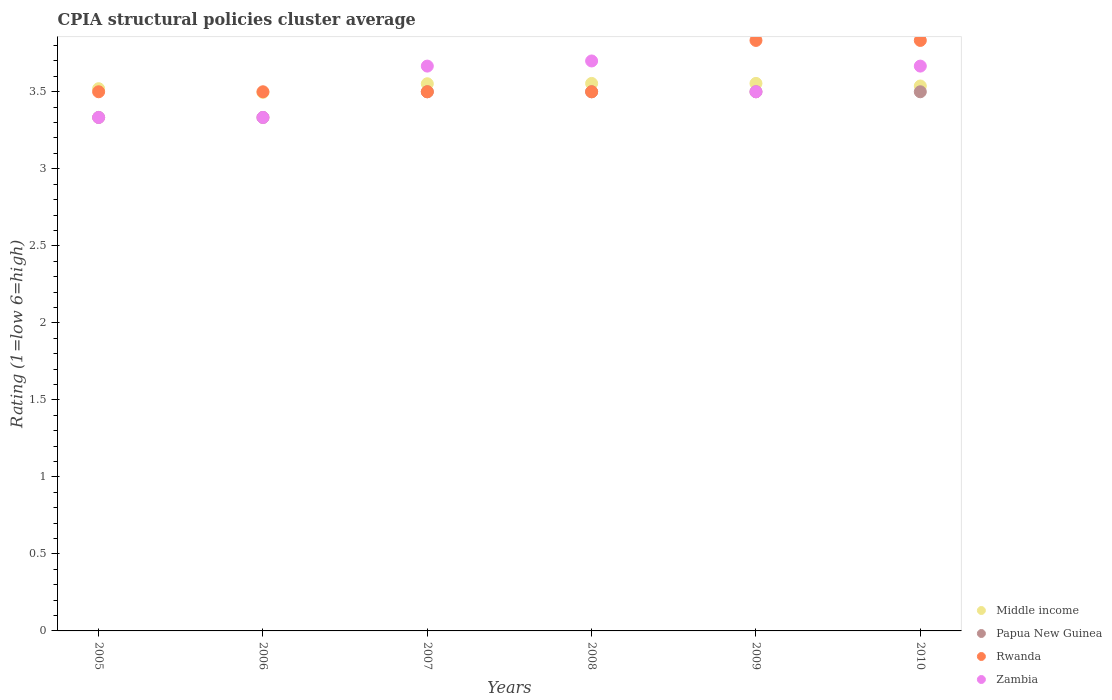What is the CPIA rating in Middle income in 2007?
Give a very brief answer. 3.55. Across all years, what is the maximum CPIA rating in Rwanda?
Provide a succinct answer. 3.83. Across all years, what is the minimum CPIA rating in Papua New Guinea?
Ensure brevity in your answer.  3.33. In which year was the CPIA rating in Rwanda minimum?
Ensure brevity in your answer.  2005. What is the total CPIA rating in Papua New Guinea in the graph?
Offer a terse response. 20.67. What is the difference between the CPIA rating in Rwanda in 2005 and that in 2008?
Your response must be concise. 0. What is the difference between the CPIA rating in Papua New Guinea in 2005 and the CPIA rating in Middle income in 2010?
Provide a short and direct response. -0.2. What is the average CPIA rating in Middle income per year?
Offer a terse response. 3.54. In the year 2005, what is the difference between the CPIA rating in Rwanda and CPIA rating in Papua New Guinea?
Provide a short and direct response. 0.17. In how many years, is the CPIA rating in Papua New Guinea greater than 3.6?
Keep it short and to the point. 0. What is the ratio of the CPIA rating in Rwanda in 2009 to that in 2010?
Provide a short and direct response. 1. What is the difference between the highest and the lowest CPIA rating in Middle income?
Offer a terse response. 0.06. In how many years, is the CPIA rating in Zambia greater than the average CPIA rating in Zambia taken over all years?
Provide a succinct answer. 3. Is the CPIA rating in Zambia strictly greater than the CPIA rating in Middle income over the years?
Make the answer very short. No. How many years are there in the graph?
Offer a terse response. 6. Are the values on the major ticks of Y-axis written in scientific E-notation?
Your answer should be compact. No. Does the graph contain any zero values?
Your answer should be very brief. No. Does the graph contain grids?
Your response must be concise. No. Where does the legend appear in the graph?
Provide a succinct answer. Bottom right. How many legend labels are there?
Give a very brief answer. 4. How are the legend labels stacked?
Keep it short and to the point. Vertical. What is the title of the graph?
Your response must be concise. CPIA structural policies cluster average. What is the label or title of the X-axis?
Your answer should be very brief. Years. What is the label or title of the Y-axis?
Offer a terse response. Rating (1=low 6=high). What is the Rating (1=low 6=high) in Middle income in 2005?
Keep it short and to the point. 3.52. What is the Rating (1=low 6=high) in Papua New Guinea in 2005?
Make the answer very short. 3.33. What is the Rating (1=low 6=high) in Zambia in 2005?
Your answer should be very brief. 3.33. What is the Rating (1=low 6=high) of Middle income in 2006?
Offer a very short reply. 3.5. What is the Rating (1=low 6=high) in Papua New Guinea in 2006?
Make the answer very short. 3.33. What is the Rating (1=low 6=high) of Rwanda in 2006?
Your answer should be compact. 3.5. What is the Rating (1=low 6=high) in Zambia in 2006?
Your answer should be very brief. 3.33. What is the Rating (1=low 6=high) of Middle income in 2007?
Make the answer very short. 3.55. What is the Rating (1=low 6=high) of Rwanda in 2007?
Your answer should be very brief. 3.5. What is the Rating (1=low 6=high) in Zambia in 2007?
Give a very brief answer. 3.67. What is the Rating (1=low 6=high) of Middle income in 2008?
Give a very brief answer. 3.55. What is the Rating (1=low 6=high) of Papua New Guinea in 2008?
Give a very brief answer. 3.5. What is the Rating (1=low 6=high) of Rwanda in 2008?
Keep it short and to the point. 3.5. What is the Rating (1=low 6=high) of Middle income in 2009?
Your response must be concise. 3.55. What is the Rating (1=low 6=high) in Rwanda in 2009?
Make the answer very short. 3.83. What is the Rating (1=low 6=high) in Zambia in 2009?
Make the answer very short. 3.5. What is the Rating (1=low 6=high) in Middle income in 2010?
Provide a short and direct response. 3.54. What is the Rating (1=low 6=high) in Papua New Guinea in 2010?
Ensure brevity in your answer.  3.5. What is the Rating (1=low 6=high) of Rwanda in 2010?
Provide a short and direct response. 3.83. What is the Rating (1=low 6=high) in Zambia in 2010?
Make the answer very short. 3.67. Across all years, what is the maximum Rating (1=low 6=high) of Middle income?
Give a very brief answer. 3.55. Across all years, what is the maximum Rating (1=low 6=high) in Papua New Guinea?
Ensure brevity in your answer.  3.5. Across all years, what is the maximum Rating (1=low 6=high) of Rwanda?
Your response must be concise. 3.83. Across all years, what is the maximum Rating (1=low 6=high) in Zambia?
Ensure brevity in your answer.  3.7. Across all years, what is the minimum Rating (1=low 6=high) of Middle income?
Offer a terse response. 3.5. Across all years, what is the minimum Rating (1=low 6=high) in Papua New Guinea?
Ensure brevity in your answer.  3.33. Across all years, what is the minimum Rating (1=low 6=high) of Rwanda?
Ensure brevity in your answer.  3.5. Across all years, what is the minimum Rating (1=low 6=high) of Zambia?
Keep it short and to the point. 3.33. What is the total Rating (1=low 6=high) of Middle income in the graph?
Your response must be concise. 21.21. What is the total Rating (1=low 6=high) of Papua New Guinea in the graph?
Offer a very short reply. 20.67. What is the total Rating (1=low 6=high) in Rwanda in the graph?
Provide a short and direct response. 21.67. What is the total Rating (1=low 6=high) of Zambia in the graph?
Keep it short and to the point. 21.2. What is the difference between the Rating (1=low 6=high) of Middle income in 2005 and that in 2006?
Your response must be concise. 0.02. What is the difference between the Rating (1=low 6=high) in Rwanda in 2005 and that in 2006?
Provide a succinct answer. 0. What is the difference between the Rating (1=low 6=high) in Zambia in 2005 and that in 2006?
Provide a short and direct response. 0. What is the difference between the Rating (1=low 6=high) in Middle income in 2005 and that in 2007?
Give a very brief answer. -0.03. What is the difference between the Rating (1=low 6=high) in Rwanda in 2005 and that in 2007?
Your answer should be very brief. 0. What is the difference between the Rating (1=low 6=high) of Middle income in 2005 and that in 2008?
Your answer should be compact. -0.03. What is the difference between the Rating (1=low 6=high) in Rwanda in 2005 and that in 2008?
Provide a succinct answer. 0. What is the difference between the Rating (1=low 6=high) of Zambia in 2005 and that in 2008?
Your answer should be compact. -0.37. What is the difference between the Rating (1=low 6=high) in Middle income in 2005 and that in 2009?
Your response must be concise. -0.03. What is the difference between the Rating (1=low 6=high) of Rwanda in 2005 and that in 2009?
Provide a short and direct response. -0.33. What is the difference between the Rating (1=low 6=high) of Zambia in 2005 and that in 2009?
Ensure brevity in your answer.  -0.17. What is the difference between the Rating (1=low 6=high) in Middle income in 2005 and that in 2010?
Provide a succinct answer. -0.02. What is the difference between the Rating (1=low 6=high) in Zambia in 2005 and that in 2010?
Keep it short and to the point. -0.33. What is the difference between the Rating (1=low 6=high) of Middle income in 2006 and that in 2007?
Provide a succinct answer. -0.06. What is the difference between the Rating (1=low 6=high) of Zambia in 2006 and that in 2007?
Give a very brief answer. -0.33. What is the difference between the Rating (1=low 6=high) of Middle income in 2006 and that in 2008?
Offer a terse response. -0.06. What is the difference between the Rating (1=low 6=high) in Rwanda in 2006 and that in 2008?
Your answer should be compact. 0. What is the difference between the Rating (1=low 6=high) of Zambia in 2006 and that in 2008?
Offer a terse response. -0.37. What is the difference between the Rating (1=low 6=high) in Middle income in 2006 and that in 2009?
Provide a short and direct response. -0.06. What is the difference between the Rating (1=low 6=high) in Zambia in 2006 and that in 2009?
Your answer should be compact. -0.17. What is the difference between the Rating (1=low 6=high) of Middle income in 2006 and that in 2010?
Offer a terse response. -0.04. What is the difference between the Rating (1=low 6=high) in Papua New Guinea in 2006 and that in 2010?
Make the answer very short. -0.17. What is the difference between the Rating (1=low 6=high) in Zambia in 2006 and that in 2010?
Keep it short and to the point. -0.33. What is the difference between the Rating (1=low 6=high) of Middle income in 2007 and that in 2008?
Ensure brevity in your answer.  -0. What is the difference between the Rating (1=low 6=high) in Papua New Guinea in 2007 and that in 2008?
Make the answer very short. 0. What is the difference between the Rating (1=low 6=high) in Rwanda in 2007 and that in 2008?
Provide a short and direct response. 0. What is the difference between the Rating (1=low 6=high) of Zambia in 2007 and that in 2008?
Your response must be concise. -0.03. What is the difference between the Rating (1=low 6=high) of Middle income in 2007 and that in 2009?
Ensure brevity in your answer.  -0. What is the difference between the Rating (1=low 6=high) of Middle income in 2007 and that in 2010?
Provide a succinct answer. 0.01. What is the difference between the Rating (1=low 6=high) of Middle income in 2008 and that in 2009?
Provide a succinct answer. -0. What is the difference between the Rating (1=low 6=high) of Zambia in 2008 and that in 2009?
Ensure brevity in your answer.  0.2. What is the difference between the Rating (1=low 6=high) of Middle income in 2008 and that in 2010?
Your response must be concise. 0.02. What is the difference between the Rating (1=low 6=high) in Papua New Guinea in 2008 and that in 2010?
Ensure brevity in your answer.  0. What is the difference between the Rating (1=low 6=high) in Rwanda in 2008 and that in 2010?
Your response must be concise. -0.33. What is the difference between the Rating (1=low 6=high) in Zambia in 2008 and that in 2010?
Your response must be concise. 0.03. What is the difference between the Rating (1=low 6=high) of Middle income in 2009 and that in 2010?
Make the answer very short. 0.02. What is the difference between the Rating (1=low 6=high) in Papua New Guinea in 2009 and that in 2010?
Give a very brief answer. 0. What is the difference between the Rating (1=low 6=high) in Zambia in 2009 and that in 2010?
Your answer should be very brief. -0.17. What is the difference between the Rating (1=low 6=high) in Middle income in 2005 and the Rating (1=low 6=high) in Papua New Guinea in 2006?
Ensure brevity in your answer.  0.19. What is the difference between the Rating (1=low 6=high) of Middle income in 2005 and the Rating (1=low 6=high) of Zambia in 2006?
Offer a very short reply. 0.19. What is the difference between the Rating (1=low 6=high) of Papua New Guinea in 2005 and the Rating (1=low 6=high) of Zambia in 2006?
Ensure brevity in your answer.  0. What is the difference between the Rating (1=low 6=high) in Middle income in 2005 and the Rating (1=low 6=high) in Papua New Guinea in 2007?
Make the answer very short. 0.02. What is the difference between the Rating (1=low 6=high) in Middle income in 2005 and the Rating (1=low 6=high) in Zambia in 2007?
Your answer should be very brief. -0.15. What is the difference between the Rating (1=low 6=high) of Rwanda in 2005 and the Rating (1=low 6=high) of Zambia in 2007?
Offer a terse response. -0.17. What is the difference between the Rating (1=low 6=high) of Middle income in 2005 and the Rating (1=low 6=high) of Papua New Guinea in 2008?
Give a very brief answer. 0.02. What is the difference between the Rating (1=low 6=high) in Middle income in 2005 and the Rating (1=low 6=high) in Zambia in 2008?
Your answer should be compact. -0.18. What is the difference between the Rating (1=low 6=high) of Papua New Guinea in 2005 and the Rating (1=low 6=high) of Rwanda in 2008?
Your response must be concise. -0.17. What is the difference between the Rating (1=low 6=high) of Papua New Guinea in 2005 and the Rating (1=low 6=high) of Zambia in 2008?
Provide a succinct answer. -0.37. What is the difference between the Rating (1=low 6=high) in Middle income in 2005 and the Rating (1=low 6=high) in Papua New Guinea in 2009?
Provide a succinct answer. 0.02. What is the difference between the Rating (1=low 6=high) of Middle income in 2005 and the Rating (1=low 6=high) of Rwanda in 2009?
Your response must be concise. -0.31. What is the difference between the Rating (1=low 6=high) of Middle income in 2005 and the Rating (1=low 6=high) of Zambia in 2009?
Ensure brevity in your answer.  0.02. What is the difference between the Rating (1=low 6=high) of Middle income in 2005 and the Rating (1=low 6=high) of Papua New Guinea in 2010?
Your response must be concise. 0.02. What is the difference between the Rating (1=low 6=high) in Middle income in 2005 and the Rating (1=low 6=high) in Rwanda in 2010?
Offer a very short reply. -0.31. What is the difference between the Rating (1=low 6=high) of Middle income in 2005 and the Rating (1=low 6=high) of Zambia in 2010?
Keep it short and to the point. -0.15. What is the difference between the Rating (1=low 6=high) of Rwanda in 2005 and the Rating (1=low 6=high) of Zambia in 2010?
Provide a short and direct response. -0.17. What is the difference between the Rating (1=low 6=high) of Middle income in 2006 and the Rating (1=low 6=high) of Papua New Guinea in 2007?
Your answer should be very brief. -0. What is the difference between the Rating (1=low 6=high) of Middle income in 2006 and the Rating (1=low 6=high) of Rwanda in 2007?
Keep it short and to the point. -0. What is the difference between the Rating (1=low 6=high) of Middle income in 2006 and the Rating (1=low 6=high) of Zambia in 2007?
Provide a short and direct response. -0.17. What is the difference between the Rating (1=low 6=high) of Rwanda in 2006 and the Rating (1=low 6=high) of Zambia in 2007?
Your response must be concise. -0.17. What is the difference between the Rating (1=low 6=high) of Middle income in 2006 and the Rating (1=low 6=high) of Papua New Guinea in 2008?
Your answer should be compact. -0. What is the difference between the Rating (1=low 6=high) in Middle income in 2006 and the Rating (1=low 6=high) in Rwanda in 2008?
Your answer should be compact. -0. What is the difference between the Rating (1=low 6=high) in Middle income in 2006 and the Rating (1=low 6=high) in Zambia in 2008?
Make the answer very short. -0.2. What is the difference between the Rating (1=low 6=high) in Papua New Guinea in 2006 and the Rating (1=low 6=high) in Zambia in 2008?
Make the answer very short. -0.37. What is the difference between the Rating (1=low 6=high) of Rwanda in 2006 and the Rating (1=low 6=high) of Zambia in 2008?
Offer a terse response. -0.2. What is the difference between the Rating (1=low 6=high) in Middle income in 2006 and the Rating (1=low 6=high) in Papua New Guinea in 2009?
Your response must be concise. -0. What is the difference between the Rating (1=low 6=high) in Middle income in 2006 and the Rating (1=low 6=high) in Rwanda in 2009?
Offer a terse response. -0.34. What is the difference between the Rating (1=low 6=high) of Middle income in 2006 and the Rating (1=low 6=high) of Zambia in 2009?
Your answer should be compact. -0. What is the difference between the Rating (1=low 6=high) of Papua New Guinea in 2006 and the Rating (1=low 6=high) of Rwanda in 2009?
Your answer should be compact. -0.5. What is the difference between the Rating (1=low 6=high) in Rwanda in 2006 and the Rating (1=low 6=high) in Zambia in 2009?
Ensure brevity in your answer.  0. What is the difference between the Rating (1=low 6=high) in Middle income in 2006 and the Rating (1=low 6=high) in Papua New Guinea in 2010?
Provide a succinct answer. -0. What is the difference between the Rating (1=low 6=high) in Middle income in 2006 and the Rating (1=low 6=high) in Rwanda in 2010?
Your answer should be compact. -0.34. What is the difference between the Rating (1=low 6=high) in Middle income in 2006 and the Rating (1=low 6=high) in Zambia in 2010?
Offer a terse response. -0.17. What is the difference between the Rating (1=low 6=high) in Papua New Guinea in 2006 and the Rating (1=low 6=high) in Rwanda in 2010?
Give a very brief answer. -0.5. What is the difference between the Rating (1=low 6=high) in Middle income in 2007 and the Rating (1=low 6=high) in Papua New Guinea in 2008?
Give a very brief answer. 0.05. What is the difference between the Rating (1=low 6=high) of Middle income in 2007 and the Rating (1=low 6=high) of Rwanda in 2008?
Your response must be concise. 0.05. What is the difference between the Rating (1=low 6=high) of Middle income in 2007 and the Rating (1=low 6=high) of Zambia in 2008?
Your response must be concise. -0.15. What is the difference between the Rating (1=low 6=high) of Papua New Guinea in 2007 and the Rating (1=low 6=high) of Rwanda in 2008?
Your response must be concise. 0. What is the difference between the Rating (1=low 6=high) of Rwanda in 2007 and the Rating (1=low 6=high) of Zambia in 2008?
Offer a very short reply. -0.2. What is the difference between the Rating (1=low 6=high) in Middle income in 2007 and the Rating (1=low 6=high) in Papua New Guinea in 2009?
Keep it short and to the point. 0.05. What is the difference between the Rating (1=low 6=high) in Middle income in 2007 and the Rating (1=low 6=high) in Rwanda in 2009?
Provide a short and direct response. -0.28. What is the difference between the Rating (1=low 6=high) of Middle income in 2007 and the Rating (1=low 6=high) of Zambia in 2009?
Your response must be concise. 0.05. What is the difference between the Rating (1=low 6=high) of Papua New Guinea in 2007 and the Rating (1=low 6=high) of Rwanda in 2009?
Offer a very short reply. -0.33. What is the difference between the Rating (1=low 6=high) of Papua New Guinea in 2007 and the Rating (1=low 6=high) of Zambia in 2009?
Provide a succinct answer. 0. What is the difference between the Rating (1=low 6=high) in Middle income in 2007 and the Rating (1=low 6=high) in Papua New Guinea in 2010?
Your answer should be compact. 0.05. What is the difference between the Rating (1=low 6=high) of Middle income in 2007 and the Rating (1=low 6=high) of Rwanda in 2010?
Give a very brief answer. -0.28. What is the difference between the Rating (1=low 6=high) of Middle income in 2007 and the Rating (1=low 6=high) of Zambia in 2010?
Give a very brief answer. -0.11. What is the difference between the Rating (1=low 6=high) of Papua New Guinea in 2007 and the Rating (1=low 6=high) of Rwanda in 2010?
Give a very brief answer. -0.33. What is the difference between the Rating (1=low 6=high) in Papua New Guinea in 2007 and the Rating (1=low 6=high) in Zambia in 2010?
Ensure brevity in your answer.  -0.17. What is the difference between the Rating (1=low 6=high) in Middle income in 2008 and the Rating (1=low 6=high) in Papua New Guinea in 2009?
Your answer should be compact. 0.05. What is the difference between the Rating (1=low 6=high) in Middle income in 2008 and the Rating (1=low 6=high) in Rwanda in 2009?
Offer a very short reply. -0.28. What is the difference between the Rating (1=low 6=high) in Middle income in 2008 and the Rating (1=low 6=high) in Zambia in 2009?
Make the answer very short. 0.05. What is the difference between the Rating (1=low 6=high) in Papua New Guinea in 2008 and the Rating (1=low 6=high) in Zambia in 2009?
Provide a succinct answer. 0. What is the difference between the Rating (1=low 6=high) in Rwanda in 2008 and the Rating (1=low 6=high) in Zambia in 2009?
Ensure brevity in your answer.  0. What is the difference between the Rating (1=low 6=high) of Middle income in 2008 and the Rating (1=low 6=high) of Papua New Guinea in 2010?
Ensure brevity in your answer.  0.05. What is the difference between the Rating (1=low 6=high) of Middle income in 2008 and the Rating (1=low 6=high) of Rwanda in 2010?
Make the answer very short. -0.28. What is the difference between the Rating (1=low 6=high) of Middle income in 2008 and the Rating (1=low 6=high) of Zambia in 2010?
Make the answer very short. -0.11. What is the difference between the Rating (1=low 6=high) of Middle income in 2009 and the Rating (1=low 6=high) of Papua New Guinea in 2010?
Ensure brevity in your answer.  0.05. What is the difference between the Rating (1=low 6=high) in Middle income in 2009 and the Rating (1=low 6=high) in Rwanda in 2010?
Ensure brevity in your answer.  -0.28. What is the difference between the Rating (1=low 6=high) of Middle income in 2009 and the Rating (1=low 6=high) of Zambia in 2010?
Ensure brevity in your answer.  -0.11. What is the difference between the Rating (1=low 6=high) in Papua New Guinea in 2009 and the Rating (1=low 6=high) in Rwanda in 2010?
Ensure brevity in your answer.  -0.33. What is the difference between the Rating (1=low 6=high) of Papua New Guinea in 2009 and the Rating (1=low 6=high) of Zambia in 2010?
Keep it short and to the point. -0.17. What is the difference between the Rating (1=low 6=high) in Rwanda in 2009 and the Rating (1=low 6=high) in Zambia in 2010?
Make the answer very short. 0.17. What is the average Rating (1=low 6=high) of Middle income per year?
Give a very brief answer. 3.54. What is the average Rating (1=low 6=high) of Papua New Guinea per year?
Your response must be concise. 3.44. What is the average Rating (1=low 6=high) in Rwanda per year?
Provide a short and direct response. 3.61. What is the average Rating (1=low 6=high) in Zambia per year?
Your answer should be very brief. 3.53. In the year 2005, what is the difference between the Rating (1=low 6=high) of Middle income and Rating (1=low 6=high) of Papua New Guinea?
Offer a very short reply. 0.19. In the year 2005, what is the difference between the Rating (1=low 6=high) of Middle income and Rating (1=low 6=high) of Rwanda?
Keep it short and to the point. 0.02. In the year 2005, what is the difference between the Rating (1=low 6=high) of Middle income and Rating (1=low 6=high) of Zambia?
Your response must be concise. 0.19. In the year 2006, what is the difference between the Rating (1=low 6=high) of Middle income and Rating (1=low 6=high) of Papua New Guinea?
Your response must be concise. 0.16. In the year 2006, what is the difference between the Rating (1=low 6=high) in Middle income and Rating (1=low 6=high) in Rwanda?
Offer a very short reply. -0. In the year 2006, what is the difference between the Rating (1=low 6=high) in Middle income and Rating (1=low 6=high) in Zambia?
Your answer should be compact. 0.16. In the year 2006, what is the difference between the Rating (1=low 6=high) of Papua New Guinea and Rating (1=low 6=high) of Rwanda?
Provide a succinct answer. -0.17. In the year 2007, what is the difference between the Rating (1=low 6=high) in Middle income and Rating (1=low 6=high) in Papua New Guinea?
Make the answer very short. 0.05. In the year 2007, what is the difference between the Rating (1=low 6=high) of Middle income and Rating (1=low 6=high) of Rwanda?
Provide a succinct answer. 0.05. In the year 2007, what is the difference between the Rating (1=low 6=high) of Middle income and Rating (1=low 6=high) of Zambia?
Your answer should be very brief. -0.11. In the year 2007, what is the difference between the Rating (1=low 6=high) of Papua New Guinea and Rating (1=low 6=high) of Zambia?
Ensure brevity in your answer.  -0.17. In the year 2008, what is the difference between the Rating (1=low 6=high) in Middle income and Rating (1=low 6=high) in Papua New Guinea?
Offer a terse response. 0.05. In the year 2008, what is the difference between the Rating (1=low 6=high) in Middle income and Rating (1=low 6=high) in Rwanda?
Provide a succinct answer. 0.05. In the year 2008, what is the difference between the Rating (1=low 6=high) in Middle income and Rating (1=low 6=high) in Zambia?
Offer a terse response. -0.15. In the year 2008, what is the difference between the Rating (1=low 6=high) of Papua New Guinea and Rating (1=low 6=high) of Zambia?
Offer a very short reply. -0.2. In the year 2008, what is the difference between the Rating (1=low 6=high) of Rwanda and Rating (1=low 6=high) of Zambia?
Provide a succinct answer. -0.2. In the year 2009, what is the difference between the Rating (1=low 6=high) of Middle income and Rating (1=low 6=high) of Papua New Guinea?
Your response must be concise. 0.05. In the year 2009, what is the difference between the Rating (1=low 6=high) of Middle income and Rating (1=low 6=high) of Rwanda?
Your answer should be very brief. -0.28. In the year 2009, what is the difference between the Rating (1=low 6=high) in Middle income and Rating (1=low 6=high) in Zambia?
Provide a succinct answer. 0.05. In the year 2009, what is the difference between the Rating (1=low 6=high) of Rwanda and Rating (1=low 6=high) of Zambia?
Make the answer very short. 0.33. In the year 2010, what is the difference between the Rating (1=low 6=high) of Middle income and Rating (1=low 6=high) of Papua New Guinea?
Provide a short and direct response. 0.04. In the year 2010, what is the difference between the Rating (1=low 6=high) in Middle income and Rating (1=low 6=high) in Rwanda?
Offer a very short reply. -0.3. In the year 2010, what is the difference between the Rating (1=low 6=high) of Middle income and Rating (1=low 6=high) of Zambia?
Make the answer very short. -0.13. In the year 2010, what is the difference between the Rating (1=low 6=high) in Papua New Guinea and Rating (1=low 6=high) in Rwanda?
Make the answer very short. -0.33. In the year 2010, what is the difference between the Rating (1=low 6=high) in Rwanda and Rating (1=low 6=high) in Zambia?
Your answer should be very brief. 0.17. What is the ratio of the Rating (1=low 6=high) of Middle income in 2005 to that in 2006?
Provide a short and direct response. 1.01. What is the ratio of the Rating (1=low 6=high) of Zambia in 2005 to that in 2006?
Ensure brevity in your answer.  1. What is the ratio of the Rating (1=low 6=high) of Papua New Guinea in 2005 to that in 2008?
Offer a very short reply. 0.95. What is the ratio of the Rating (1=low 6=high) of Rwanda in 2005 to that in 2008?
Provide a short and direct response. 1. What is the ratio of the Rating (1=low 6=high) of Zambia in 2005 to that in 2008?
Provide a succinct answer. 0.9. What is the ratio of the Rating (1=low 6=high) of Middle income in 2005 to that in 2009?
Provide a short and direct response. 0.99. What is the ratio of the Rating (1=low 6=high) in Middle income in 2006 to that in 2007?
Give a very brief answer. 0.98. What is the ratio of the Rating (1=low 6=high) in Middle income in 2006 to that in 2008?
Your answer should be very brief. 0.98. What is the ratio of the Rating (1=low 6=high) in Papua New Guinea in 2006 to that in 2008?
Make the answer very short. 0.95. What is the ratio of the Rating (1=low 6=high) of Zambia in 2006 to that in 2008?
Offer a very short reply. 0.9. What is the ratio of the Rating (1=low 6=high) of Middle income in 2006 to that in 2009?
Offer a very short reply. 0.98. What is the ratio of the Rating (1=low 6=high) of Papua New Guinea in 2006 to that in 2009?
Provide a succinct answer. 0.95. What is the ratio of the Rating (1=low 6=high) of Rwanda in 2006 to that in 2009?
Ensure brevity in your answer.  0.91. What is the ratio of the Rating (1=low 6=high) of Zambia in 2006 to that in 2009?
Provide a short and direct response. 0.95. What is the ratio of the Rating (1=low 6=high) of Middle income in 2006 to that in 2010?
Make the answer very short. 0.99. What is the ratio of the Rating (1=low 6=high) in Zambia in 2006 to that in 2010?
Make the answer very short. 0.91. What is the ratio of the Rating (1=low 6=high) in Middle income in 2007 to that in 2008?
Offer a terse response. 1. What is the ratio of the Rating (1=low 6=high) in Zambia in 2007 to that in 2008?
Your answer should be very brief. 0.99. What is the ratio of the Rating (1=low 6=high) of Middle income in 2007 to that in 2009?
Keep it short and to the point. 1. What is the ratio of the Rating (1=low 6=high) in Papua New Guinea in 2007 to that in 2009?
Offer a very short reply. 1. What is the ratio of the Rating (1=low 6=high) of Zambia in 2007 to that in 2009?
Your answer should be compact. 1.05. What is the ratio of the Rating (1=low 6=high) in Papua New Guinea in 2007 to that in 2010?
Make the answer very short. 1. What is the ratio of the Rating (1=low 6=high) in Rwanda in 2007 to that in 2010?
Offer a terse response. 0.91. What is the ratio of the Rating (1=low 6=high) of Zambia in 2007 to that in 2010?
Your response must be concise. 1. What is the ratio of the Rating (1=low 6=high) in Papua New Guinea in 2008 to that in 2009?
Your answer should be compact. 1. What is the ratio of the Rating (1=low 6=high) in Rwanda in 2008 to that in 2009?
Offer a terse response. 0.91. What is the ratio of the Rating (1=low 6=high) of Zambia in 2008 to that in 2009?
Provide a succinct answer. 1.06. What is the ratio of the Rating (1=low 6=high) of Papua New Guinea in 2008 to that in 2010?
Offer a very short reply. 1. What is the ratio of the Rating (1=low 6=high) in Rwanda in 2008 to that in 2010?
Your response must be concise. 0.91. What is the ratio of the Rating (1=low 6=high) of Zambia in 2008 to that in 2010?
Make the answer very short. 1.01. What is the ratio of the Rating (1=low 6=high) of Zambia in 2009 to that in 2010?
Make the answer very short. 0.95. What is the difference between the highest and the second highest Rating (1=low 6=high) of Middle income?
Your answer should be compact. 0. What is the difference between the highest and the second highest Rating (1=low 6=high) of Papua New Guinea?
Offer a very short reply. 0. What is the difference between the highest and the second highest Rating (1=low 6=high) in Zambia?
Offer a very short reply. 0.03. What is the difference between the highest and the lowest Rating (1=low 6=high) in Middle income?
Make the answer very short. 0.06. What is the difference between the highest and the lowest Rating (1=low 6=high) of Rwanda?
Ensure brevity in your answer.  0.33. What is the difference between the highest and the lowest Rating (1=low 6=high) in Zambia?
Offer a terse response. 0.37. 